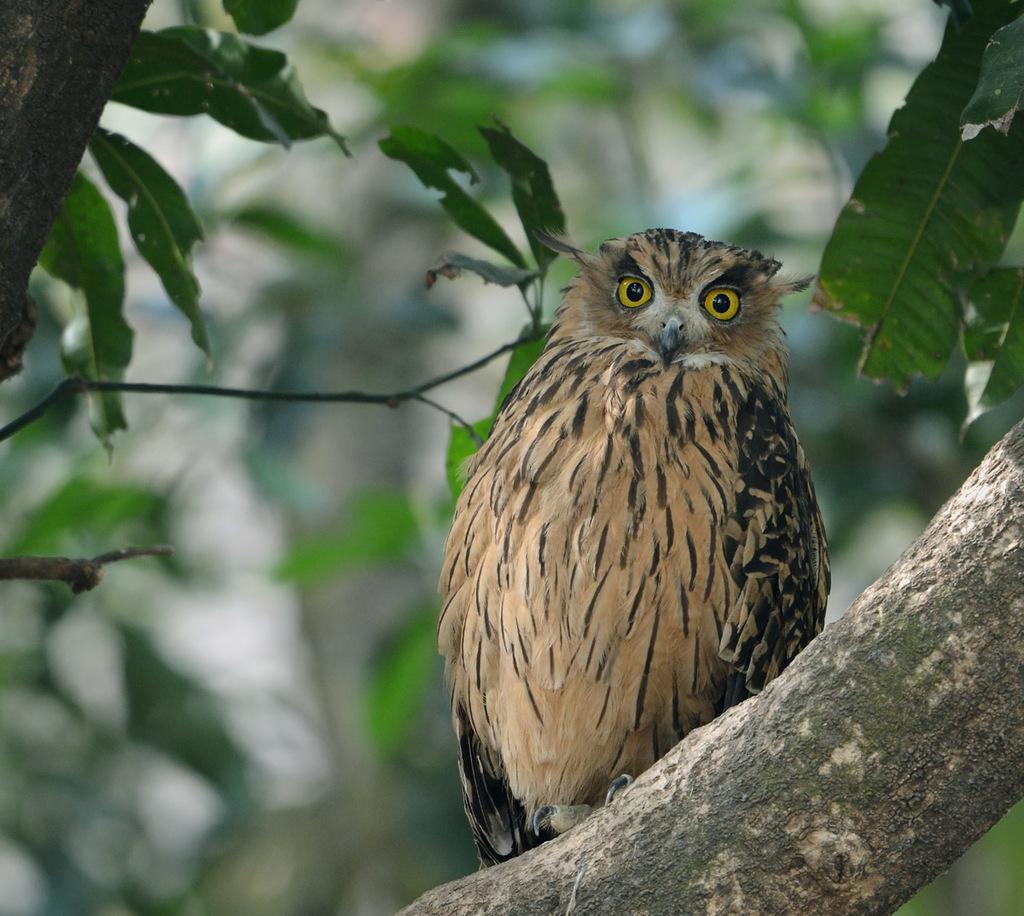Describe this image in one or two sentences. In the center of the image there is a owl on the tree. In the background we can see tree. 